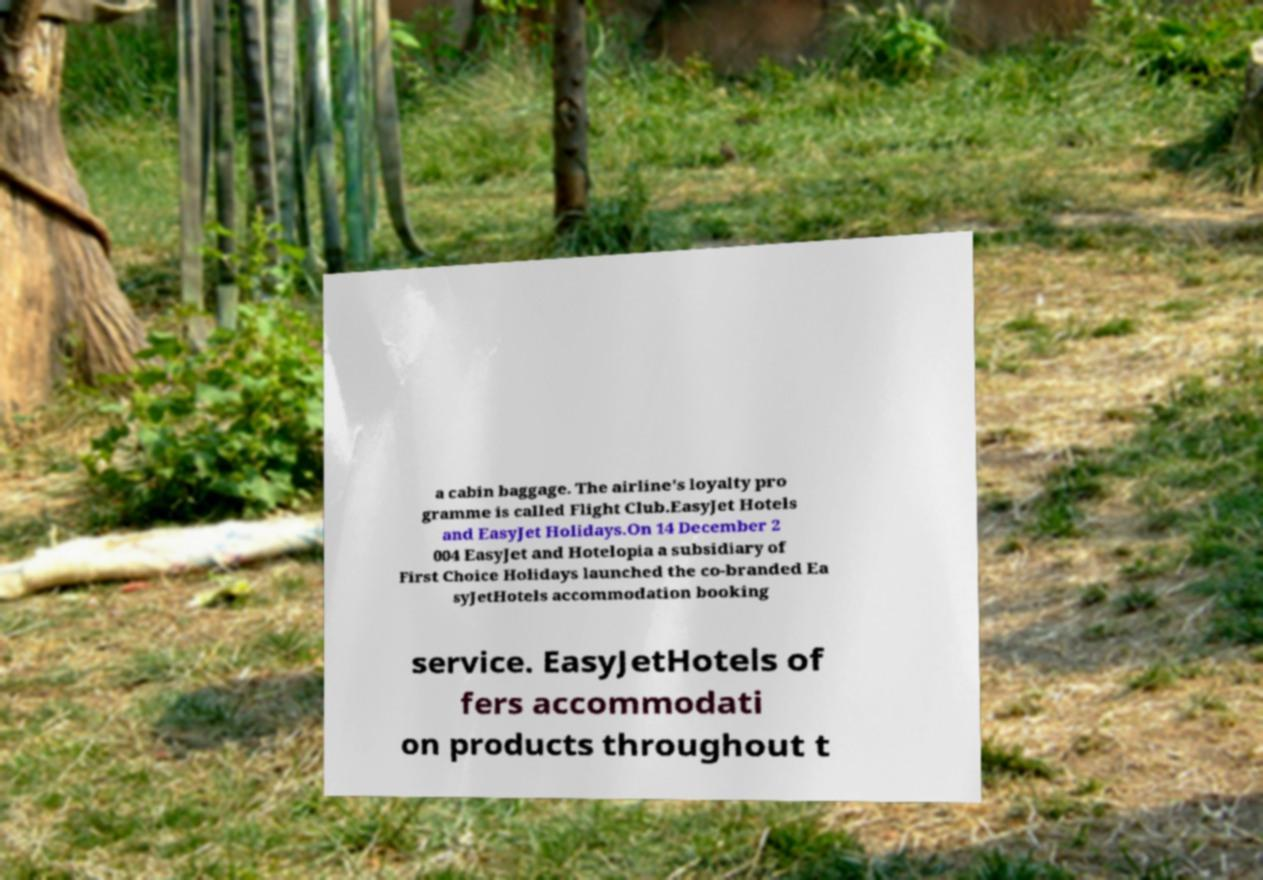Please identify and transcribe the text found in this image. a cabin baggage. The airline's loyalty pro gramme is called Flight Club.EasyJet Hotels and EasyJet Holidays.On 14 December 2 004 EasyJet and Hotelopia a subsidiary of First Choice Holidays launched the co-branded Ea syJetHotels accommodation booking service. EasyJetHotels of fers accommodati on products throughout t 